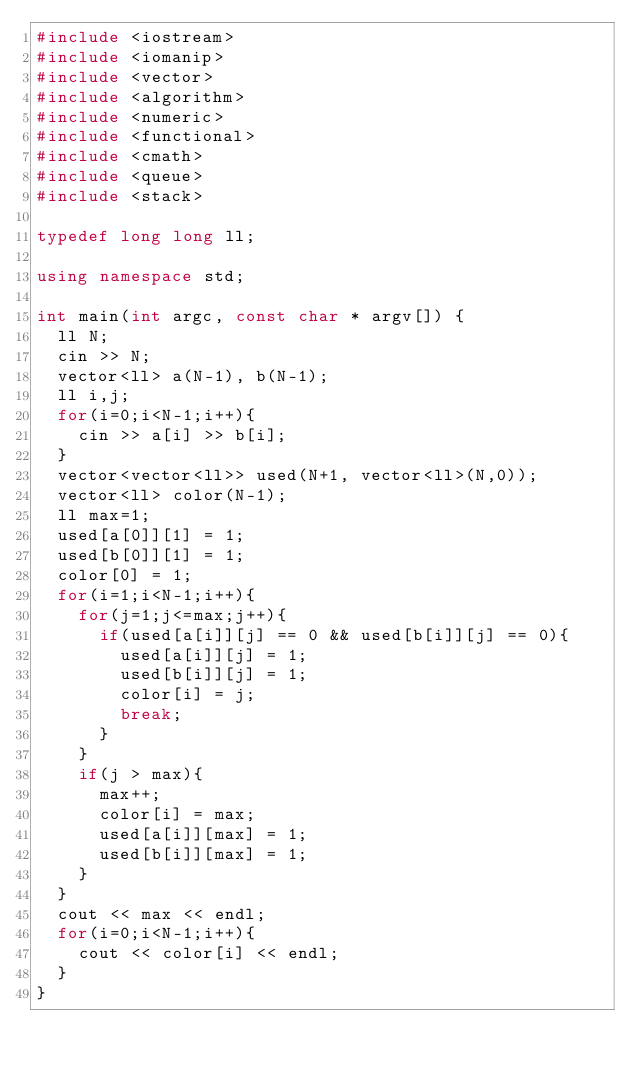<code> <loc_0><loc_0><loc_500><loc_500><_C++_>#include <iostream>
#include <iomanip>
#include <vector>
#include <algorithm>
#include <numeric>
#include <functional>
#include <cmath>
#include <queue>
#include <stack>

typedef long long ll;

using namespace std;

int main(int argc, const char * argv[]) {
  ll N;
  cin >> N;
  vector<ll> a(N-1), b(N-1);
  ll i,j;
  for(i=0;i<N-1;i++){
    cin >> a[i] >> b[i];
  }
  vector<vector<ll>> used(N+1, vector<ll>(N,0));
  vector<ll> color(N-1);
  ll max=1;
  used[a[0]][1] = 1;
  used[b[0]][1] = 1;
  color[0] = 1;
  for(i=1;i<N-1;i++){
    for(j=1;j<=max;j++){
      if(used[a[i]][j] == 0 && used[b[i]][j] == 0){
        used[a[i]][j] = 1;
        used[b[i]][j] = 1;
        color[i] = j;
        break;
      }
    }
    if(j > max){
      max++;
      color[i] = max;
      used[a[i]][max] = 1;
      used[b[i]][max] = 1;
    }
  }
  cout << max << endl;
  for(i=0;i<N-1;i++){
    cout << color[i] << endl;
  }
}

</code> 